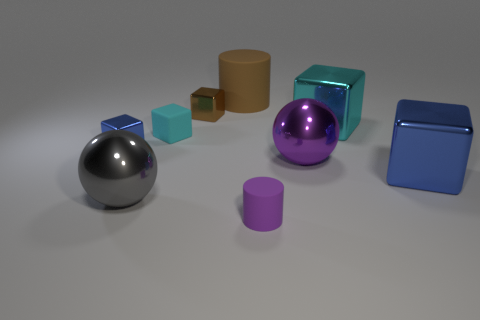There is a large thing that is the same color as the rubber cube; what material is it?
Your answer should be compact. Metal. How many brown things have the same shape as the large cyan object?
Give a very brief answer. 1. Are there more large shiny things that are left of the large cyan block than big purple rubber cylinders?
Your response must be concise. Yes. The cyan object that is to the left of the tiny object that is to the right of the tiny shiny block that is right of the big gray sphere is what shape?
Your response must be concise. Cube. Is the shape of the small thing that is on the left side of the big gray sphere the same as the blue metallic object that is on the right side of the small cylinder?
Your response must be concise. Yes. Is there anything else that has the same size as the cyan matte thing?
Your answer should be compact. Yes. How many cubes are either big shiny objects or yellow objects?
Ensure brevity in your answer.  2. Is the tiny cyan block made of the same material as the big blue cube?
Provide a succinct answer. No. How many other things are the same color as the small cylinder?
Offer a very short reply. 1. The large metal object that is in front of the large blue object has what shape?
Your answer should be compact. Sphere. 